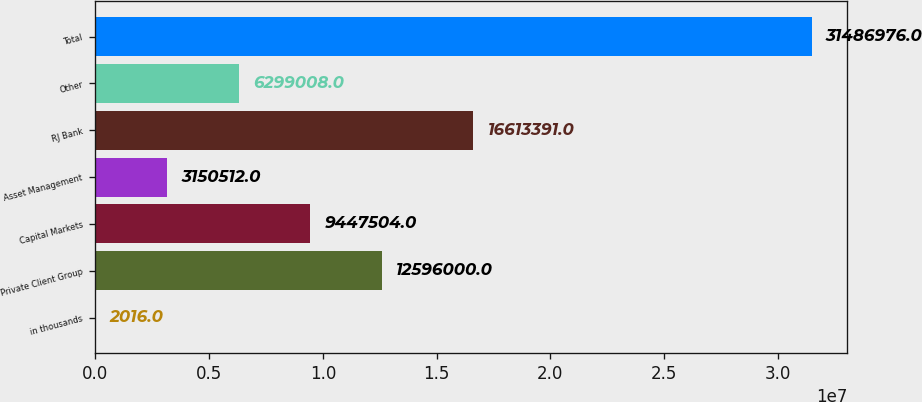<chart> <loc_0><loc_0><loc_500><loc_500><bar_chart><fcel>in thousands<fcel>Private Client Group<fcel>Capital Markets<fcel>Asset Management<fcel>RJ Bank<fcel>Other<fcel>Total<nl><fcel>2016<fcel>1.2596e+07<fcel>9.4475e+06<fcel>3.15051e+06<fcel>1.66134e+07<fcel>6.29901e+06<fcel>3.1487e+07<nl></chart> 